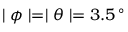Convert formula to latex. <formula><loc_0><loc_0><loc_500><loc_500>| \phi | = | \theta | = 3 . 5 \, ^ { \circ }</formula> 